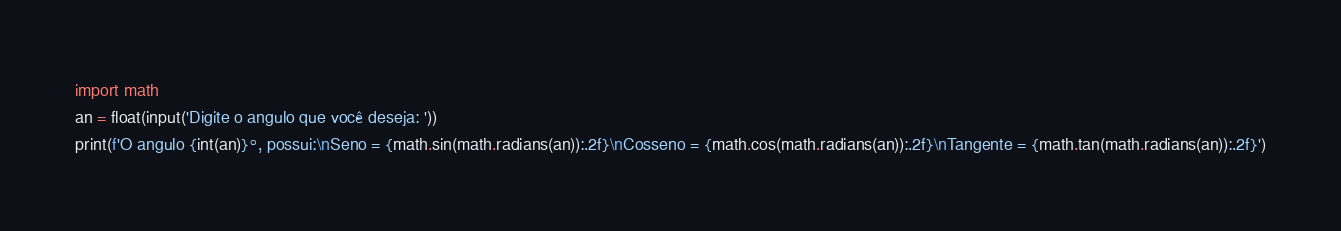Convert code to text. <code><loc_0><loc_0><loc_500><loc_500><_Python_>import math
an = float(input('Digite o angulo que você deseja: '))
print(f'O angulo {int(an)}°, possui:\nSeno = {math.sin(math.radians(an)):.2f}\nCosseno = {math.cos(math.radians(an)):.2f}\nTangente = {math.tan(math.radians(an)):.2f}')</code> 